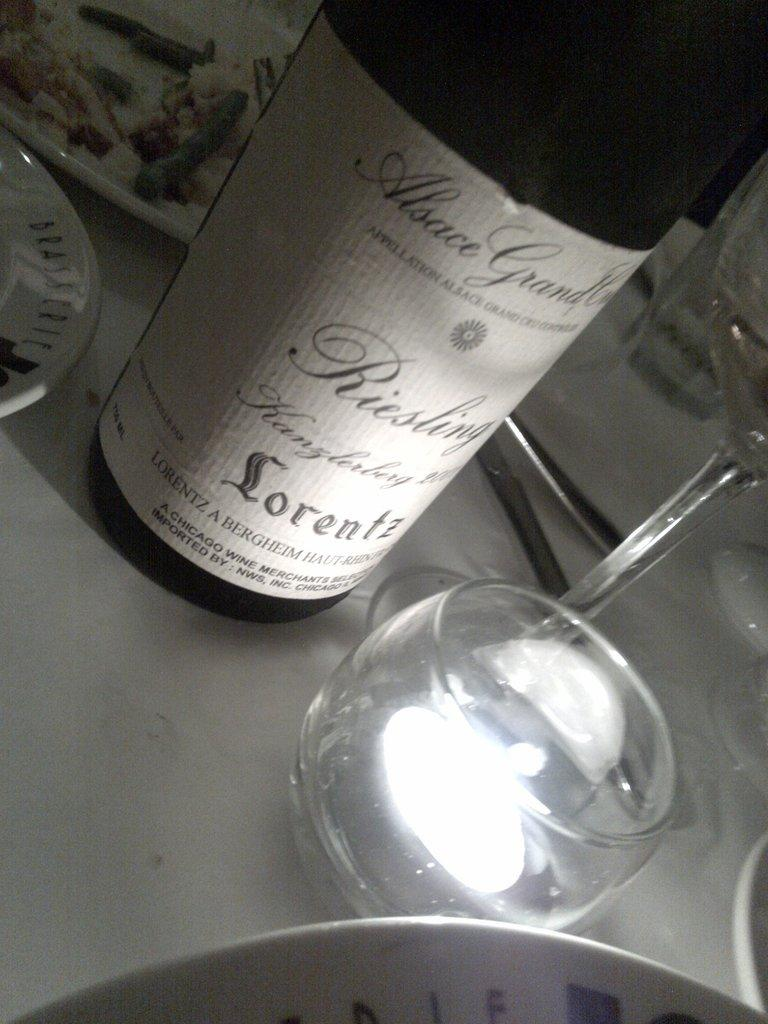Provide a one-sentence caption for the provided image. the word lorentz that is on a bottle. 